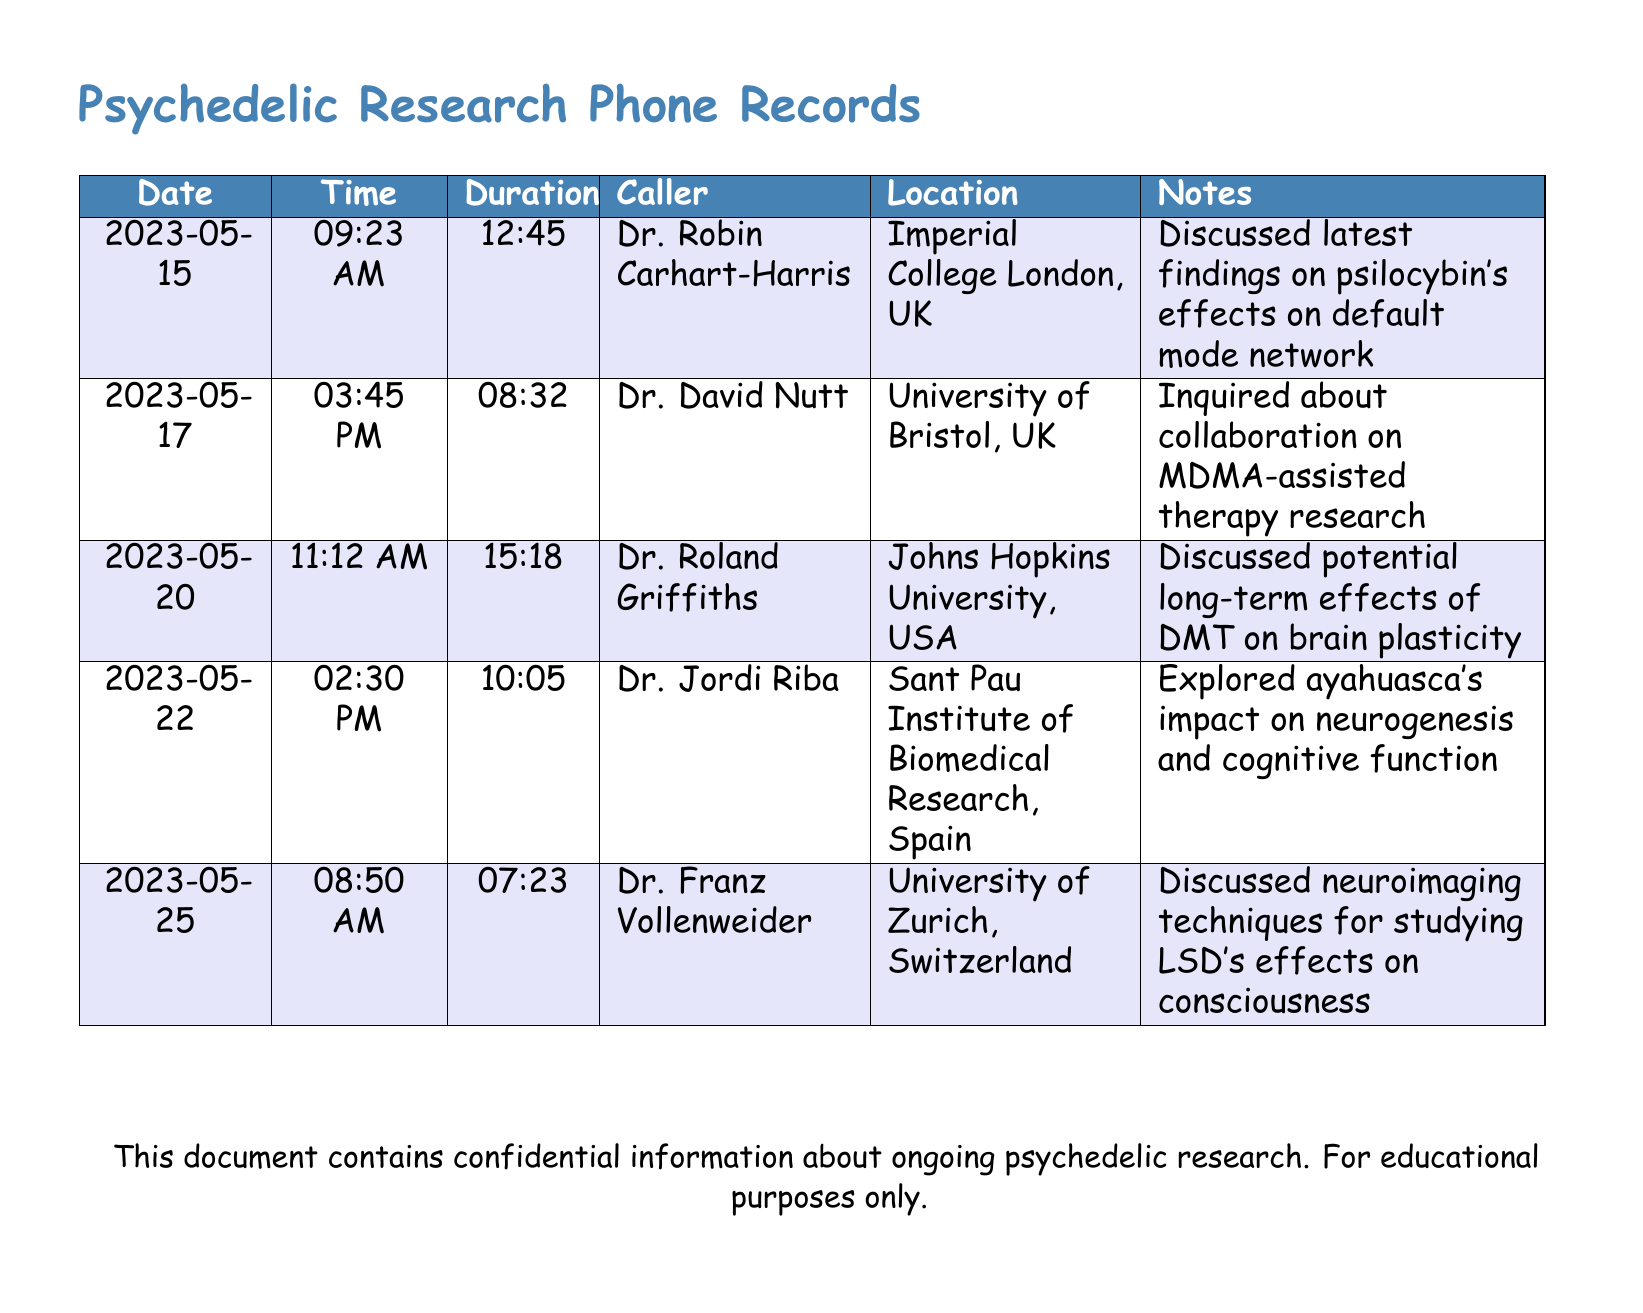What is the date of the call with Dr. Robin Carhart-Harris? The document lists the call with Dr. Robin Carhart-Harris on May 15, 2023.
Answer: May 15, 2023 How long was the call with Dr. David Nutt? The duration of the call with Dr. David Nutt is specified as 8 minutes and 32 seconds.
Answer: 08:32 Which neuroscientist is associated with Johns Hopkins University? The document states that Dr. Roland Griffiths is associated with Johns Hopkins University.
Answer: Dr. Roland Griffiths What is the main topic discussed in the call with Dr. Jordi Riba? The call with Dr. Jordi Riba explores ayahuasca's impact on neurogenesis and cognitive function.
Answer: Ayahuasca's impact on neurogenesis How many minutes long was the shortest call recorded? By examining the durations, the shortest call is with Dr. Franz Vollenweider, lasting for 7 minutes and 23 seconds.
Answer: 07:23 Which country is Dr. Franz Vollenweider from? The document states that Dr. Franz Vollenweider is from Switzerland.
Answer: Switzerland Who made inquiries about collaboration on MDMA-assisted therapy research? The document lists Dr. David Nutt as the caller who made inquiries about collaboration.
Answer: Dr. David Nutt What is the common focus of the calls in this document? The document indicates that all calls focus on aspects of psychedelic research and its effects on consciousness.
Answer: Psychedelic research 